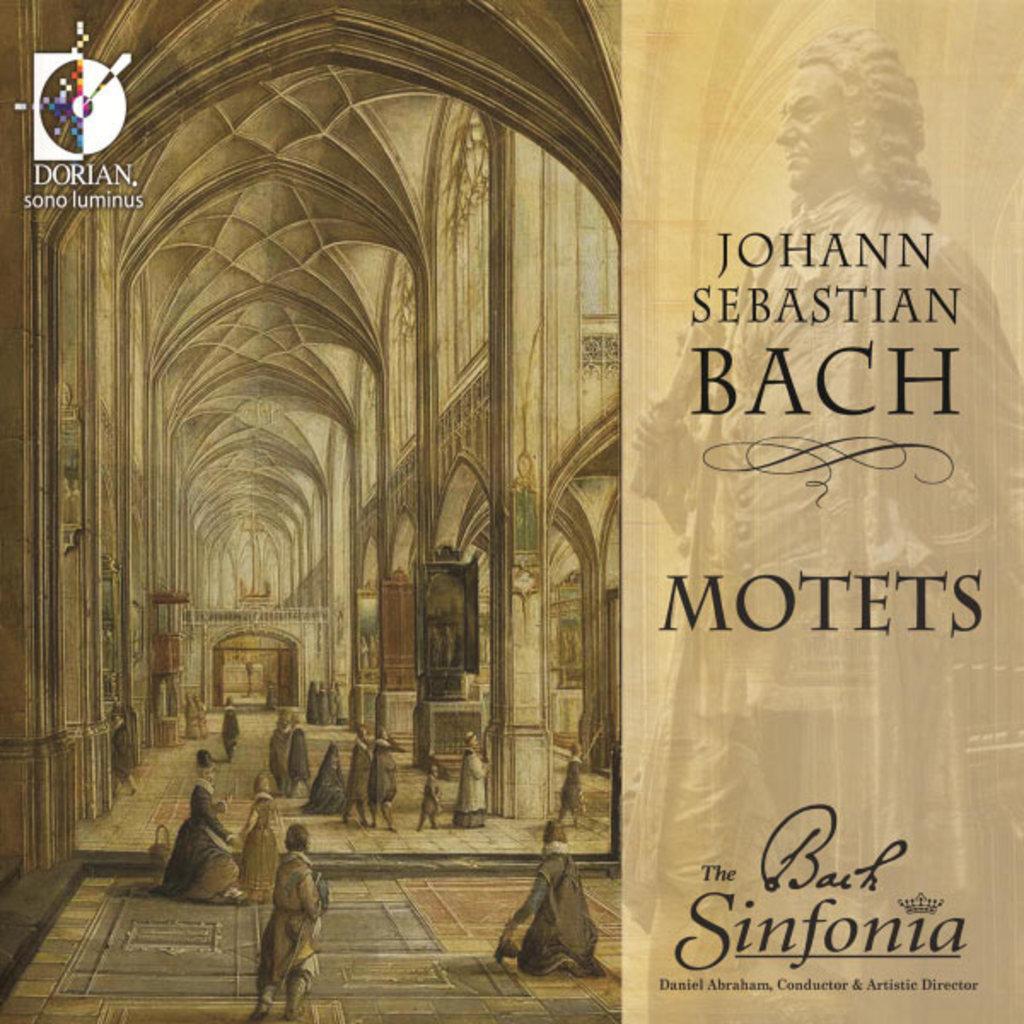Who is the composer?
Your response must be concise. Johann sebastian bach. 